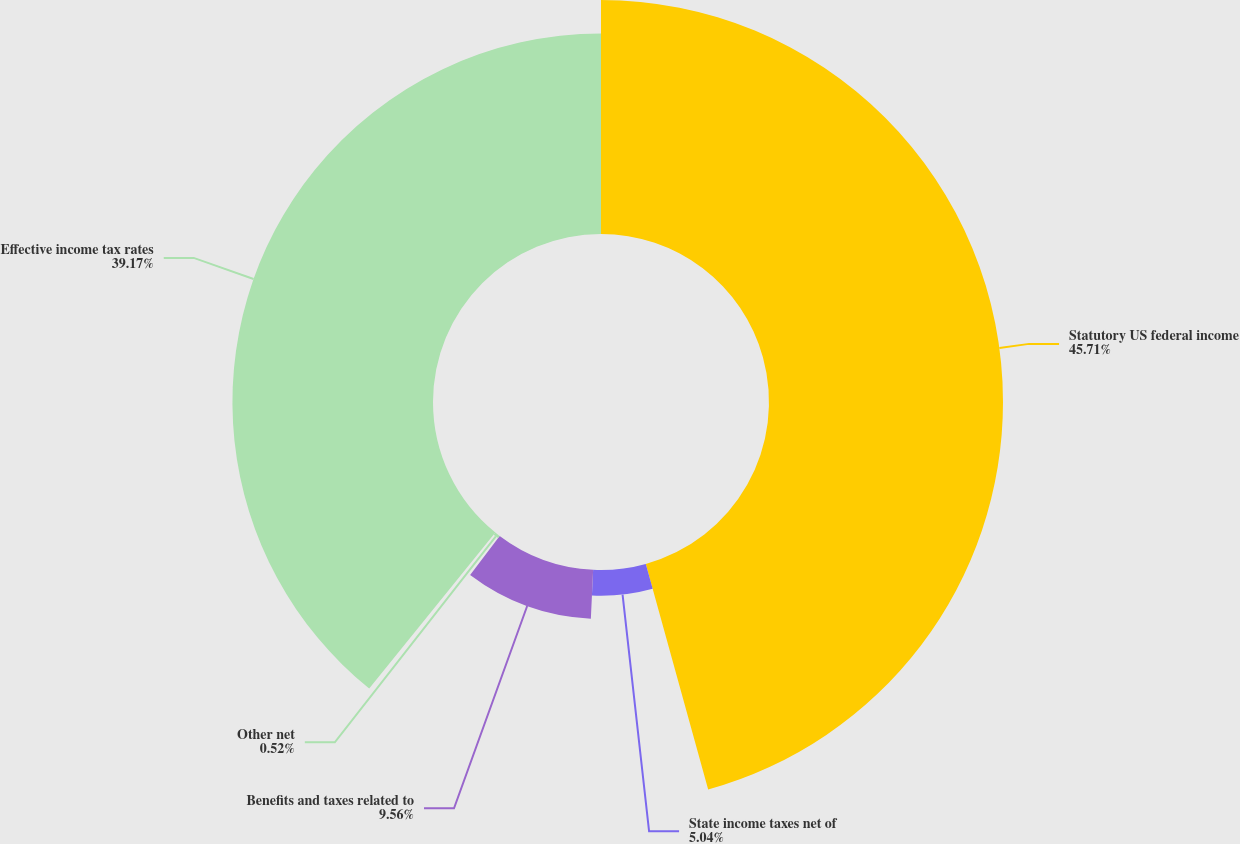<chart> <loc_0><loc_0><loc_500><loc_500><pie_chart><fcel>Statutory US federal income<fcel>State income taxes net of<fcel>Benefits and taxes related to<fcel>Other net<fcel>Effective income tax rates<nl><fcel>45.7%<fcel>5.04%<fcel>9.56%<fcel>0.52%<fcel>39.17%<nl></chart> 